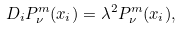<formula> <loc_0><loc_0><loc_500><loc_500>D _ { i } P _ { \nu } ^ { m } ( x _ { i } ) = \lambda ^ { 2 } P _ { \nu } ^ { m } ( x _ { i } ) ,</formula> 